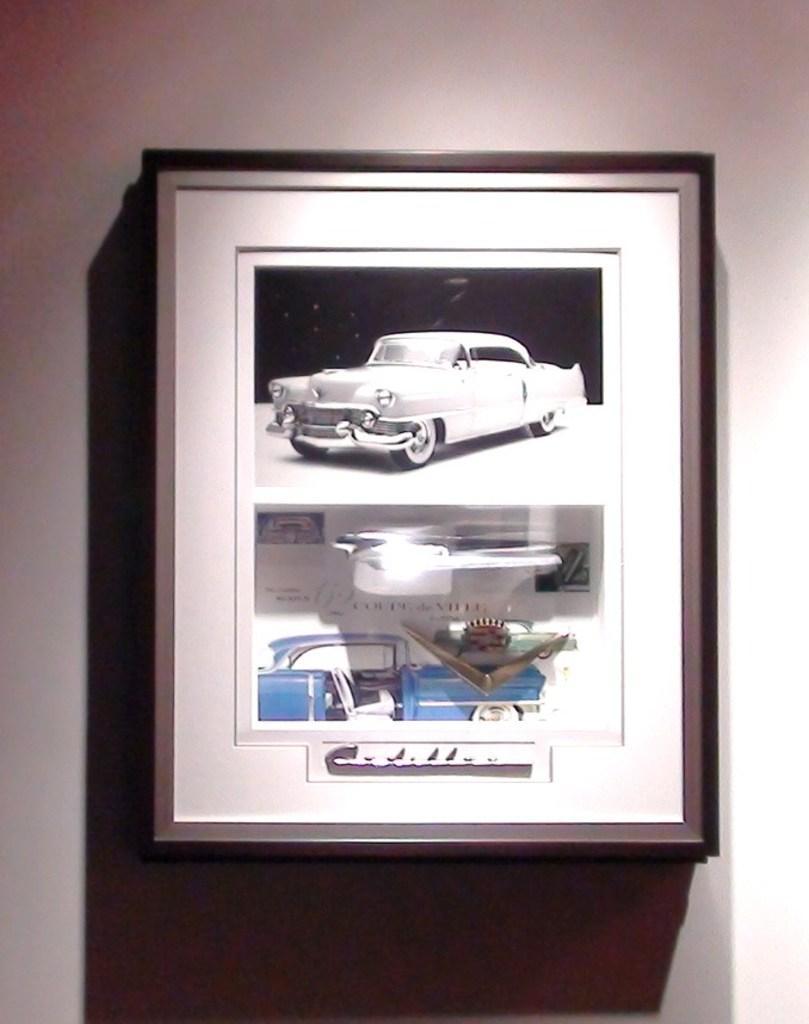How would you summarize this image in a sentence or two? In this image we can see a photo frame to the wall. In the photo frame we can see a cars. 